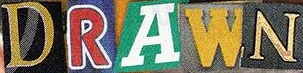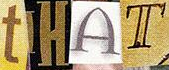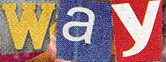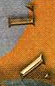What words are shown in these images in order, separated by a semicolon? DRAWN; tHAT; way; AL 